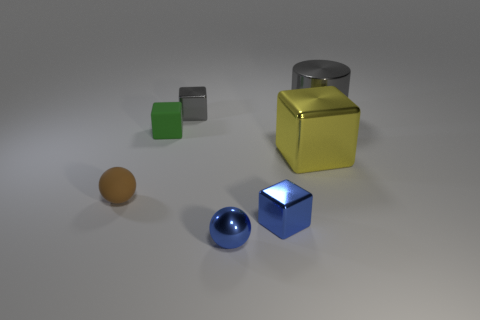What number of other objects are there of the same color as the shiny sphere?
Offer a very short reply. 1. The other thing that is the same shape as the small brown matte object is what color?
Offer a very short reply. Blue. Are there any other things that are the same shape as the large gray object?
Your answer should be very brief. No. What number of balls are either cyan things or small matte things?
Your answer should be compact. 1. The big gray thing is what shape?
Your answer should be compact. Cylinder. Are there any small brown objects to the left of the large gray metallic cylinder?
Keep it short and to the point. Yes. Is the yellow object made of the same material as the sphere behind the tiny blue shiny block?
Provide a short and direct response. No. Is the shape of the large object in front of the tiny green rubber object the same as  the small gray metal object?
Keep it short and to the point. Yes. How many green things have the same material as the green block?
Provide a succinct answer. 0. How many objects are big shiny objects that are behind the tiny green rubber thing or tiny things?
Your response must be concise. 6. 